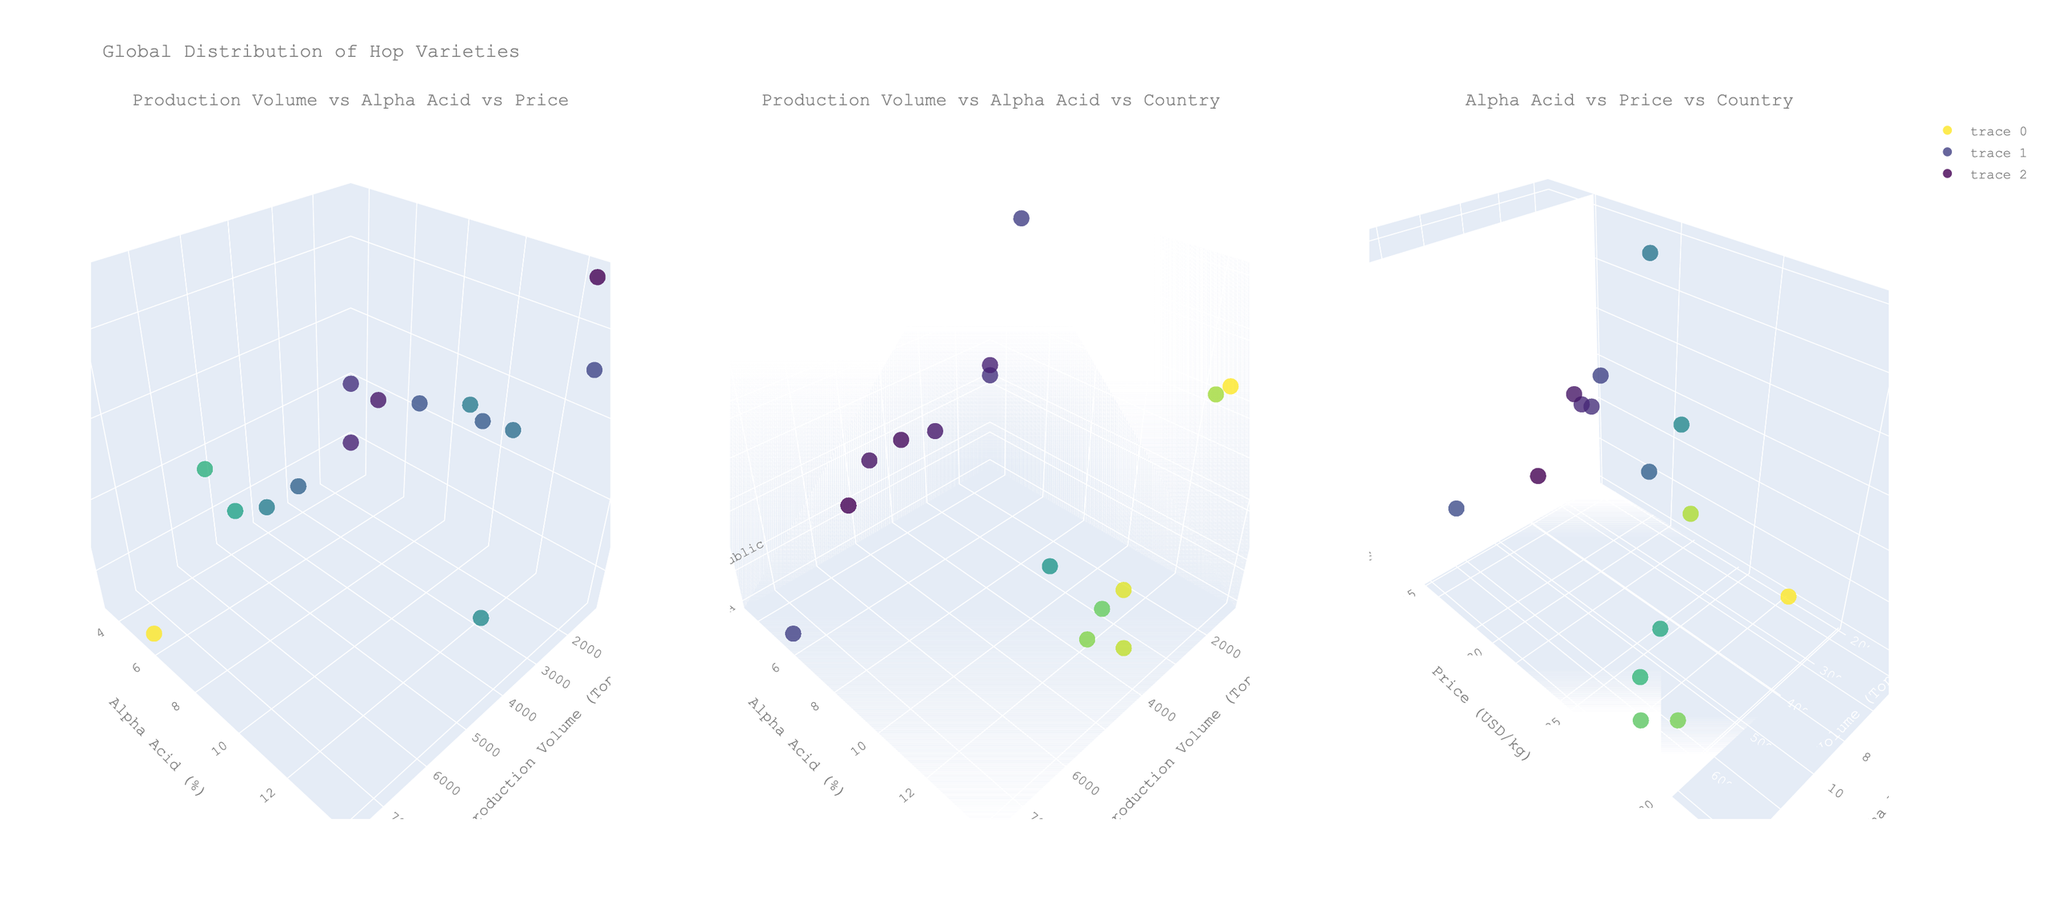What is the title of the 3D plot? The title is displayed at the top of the figure, across all subplots. This element gives an overall description of what the data represents.
Answer: Global Distribution of Hop Varieties What are the axis labels for the first subplot? To understand the axes, look at the titles on each subplot's x, y, and z axes. For the first subplot, they are labeled "Production Volume (Tons)", "Alpha Acid (%)", and "Price (USD/kg)".
Answer: Production Volume (Tons), Alpha Acid (%), Price (USD/kg) Which hop variety has the highest Alpha Acid content? Locate the highest point on the y-axis representing Alpha Acid Percentage in any subplot where alpha content is visualized. The variety with the highest alpha content is noted in the hover text. From the data, it's Nelson Sauvin with an Alpha Acid percentage of 12.5%.
Answer: Nelson Sauvin Compare the Market Price (USD per kg) of Cascade and Citra hop varieties. Which one is higher? Look for Cascade and Citra in the hover texts in any relevant subplot. Then compare their positions on the Price axis (z-axis in the first subplot). Cascade is priced at $12.50/kg and Citra at $28.50/kg.
Answer: Citra Which country has the lowest production volume for hops? Find the lowest point on the Production Volume axis (x-axis in the first or second subplot). Check the corresponding country in the hover text. From the data, it’s New Zealand (1200 tons).
Answer: New Zealand How does the Market Price generally correlate with Alpha Acid content? Observe the third subplot specifically, which plots Alpha Acid Percentage against Market Price. By visually analyzing the trend of the marker points, as Alpha Acid content increases, the market price tends to increase too, indicating a positive correlation.
Answer: Positive correlation What's the total production volume for hop varieties in the USA? Sum the Production Volume of Cascade (7500 tons), Citra (3800 tons), Mosaic (3000 tons), Amarillo (2800 tons), and Simcoe (3500 tons). The total is 20600 tons.
Answer: 20600 tons Which hop variety is produced in the Czech Republic and what is its Alpha Acid content? Find the Czech Republic in the Country axis (z-axis in the second subplot), and check the corresponding Alpha Acid Percentage in the hover text. The hop variety is Saaz with an Alpha Acid content of 3.5%.
Answer: Saaz, 3.5% Compare the Alpha Acid content of Magnum and Galaxy. Which one has a higher content? From the hover texts and the Alpha Acid axis, locate and compare Magnum and Galaxy. Magnum has an Alpha Acid content of 13.5% while Galaxy has 14%.
Answer: Galaxy On average, do German hop varieties have higher or lower Alpha Acid content compared to American varieties? Calculate the average Alpha Acid content for German varieties (Hallertau Mittelfrüh, Tettnang, Magnum, Hersbrucker) and American varieties (Cascade, Citra, Mosaic, Amarillo, Simcoe). Compare the averages: German = (4 + 4.2 + 13.5 + 3.8)/4 = 6.38%, American = (5.5 + 12 + 11.5 + 9 + 13)/5 = 10.2%.
Answer: American varieties have higher average Alpha Acid content 